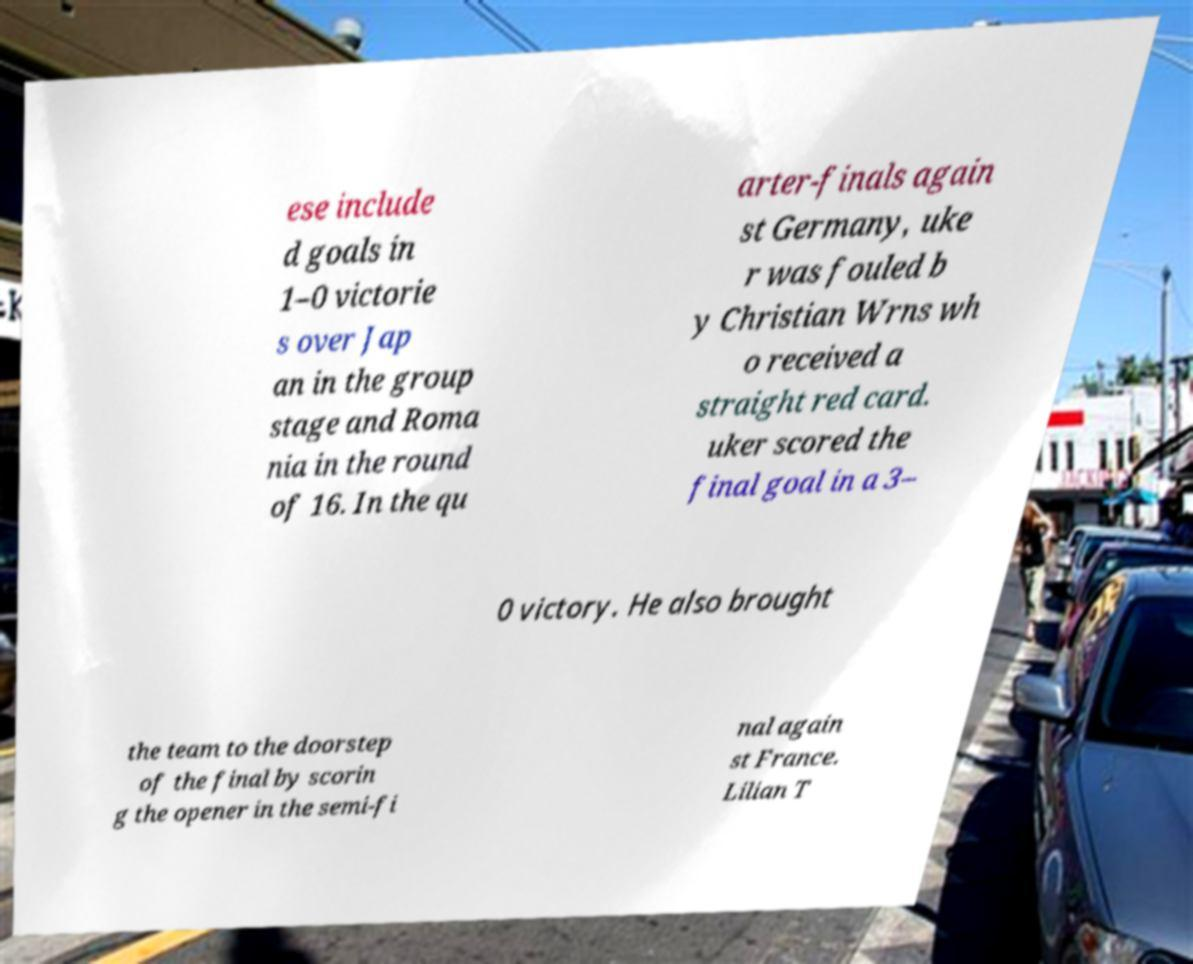Can you accurately transcribe the text from the provided image for me? ese include d goals in 1–0 victorie s over Jap an in the group stage and Roma nia in the round of 16. In the qu arter-finals again st Germany, uke r was fouled b y Christian Wrns wh o received a straight red card. uker scored the final goal in a 3– 0 victory. He also brought the team to the doorstep of the final by scorin g the opener in the semi-fi nal again st France. Lilian T 